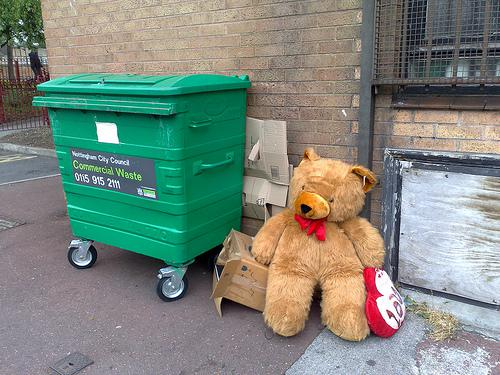Question: who is to the right of the trash can?
Choices:
A. The trash collector.
B. A teddy bear.
C. A homeless person.
D. The shop keeper.
Answer with the letter. Answer: B Question: what color is the bear?
Choices:
A. Brown.
B. Black.
C. Red.
D. White.
Answer with the letter. Answer: A Question: how many teddy bears are there?
Choices:
A. Two.
B. Five.
C. One.
D. None.
Answer with the letter. Answer: C 